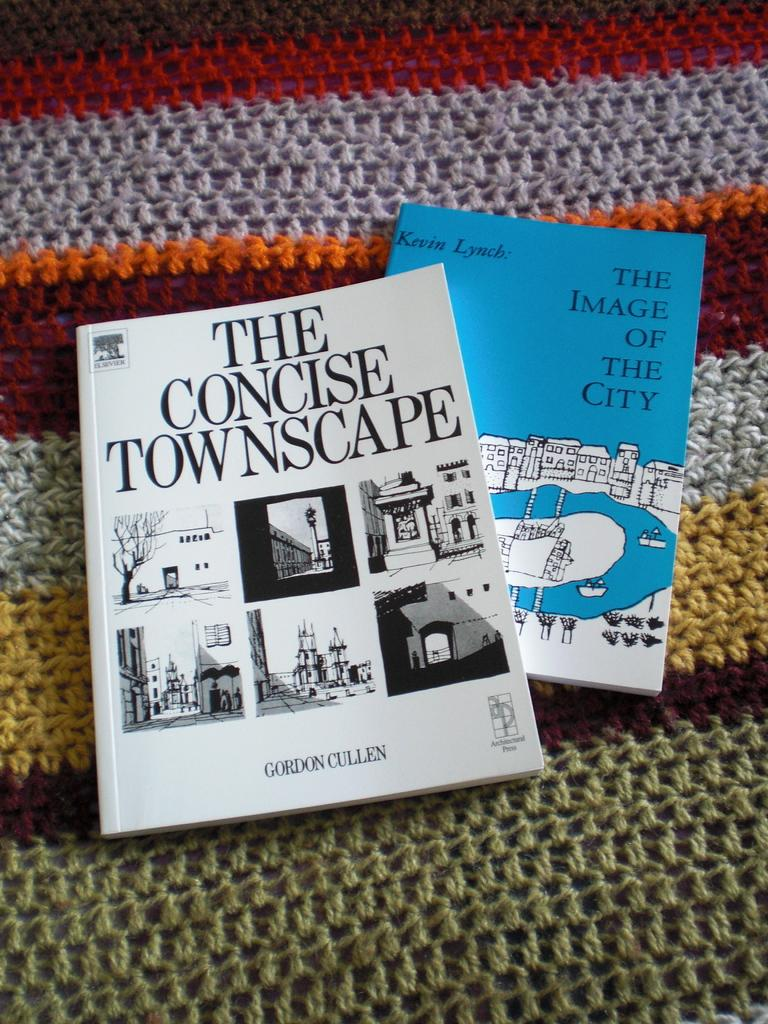Provide a one-sentence caption for the provided image. A book called The Concise Townscape and another called The Image of the City rest on top of a knitted afghan. 